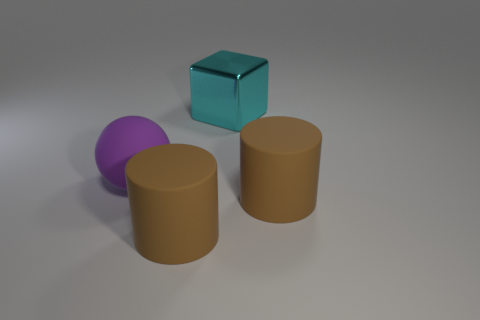There is a thing in front of the thing right of the cyan shiny object; is there a large cylinder behind it?
Offer a very short reply. Yes. What number of objects are to the left of the metallic thing and right of the cyan block?
Provide a short and direct response. 0. What shape is the purple object?
Give a very brief answer. Sphere. How many other objects are the same material as the large cube?
Your answer should be very brief. 0. What is the color of the cylinder that is right of the rubber cylinder that is to the left of the thing behind the big matte sphere?
Give a very brief answer. Brown. What is the material of the cube that is the same size as the purple rubber object?
Offer a very short reply. Metal. What number of objects are either things that are in front of the large purple sphere or large spheres?
Give a very brief answer. 3. Are there any large cubes?
Keep it short and to the point. Yes. What is the material of the cylinder that is right of the cyan object?
Your answer should be compact. Rubber. What number of big objects are cylinders or purple matte balls?
Offer a terse response. 3. 